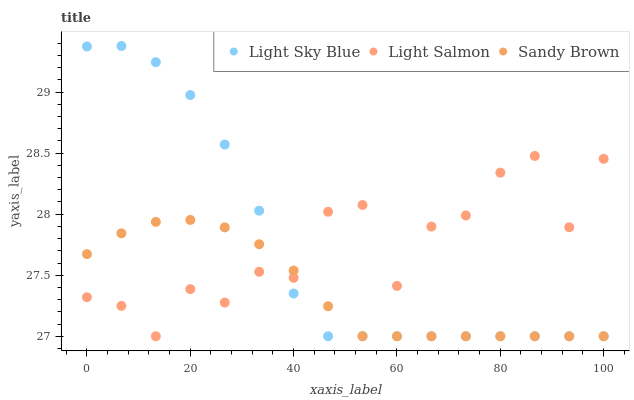Does Sandy Brown have the minimum area under the curve?
Answer yes or no. Yes. Does Light Salmon have the maximum area under the curve?
Answer yes or no. Yes. Does Light Sky Blue have the minimum area under the curve?
Answer yes or no. No. Does Light Sky Blue have the maximum area under the curve?
Answer yes or no. No. Is Sandy Brown the smoothest?
Answer yes or no. Yes. Is Light Salmon the roughest?
Answer yes or no. Yes. Is Light Sky Blue the smoothest?
Answer yes or no. No. Is Light Sky Blue the roughest?
Answer yes or no. No. Does Light Salmon have the lowest value?
Answer yes or no. Yes. Does Light Sky Blue have the highest value?
Answer yes or no. Yes. Does Sandy Brown have the highest value?
Answer yes or no. No. Does Light Sky Blue intersect Light Salmon?
Answer yes or no. Yes. Is Light Sky Blue less than Light Salmon?
Answer yes or no. No. Is Light Sky Blue greater than Light Salmon?
Answer yes or no. No. 